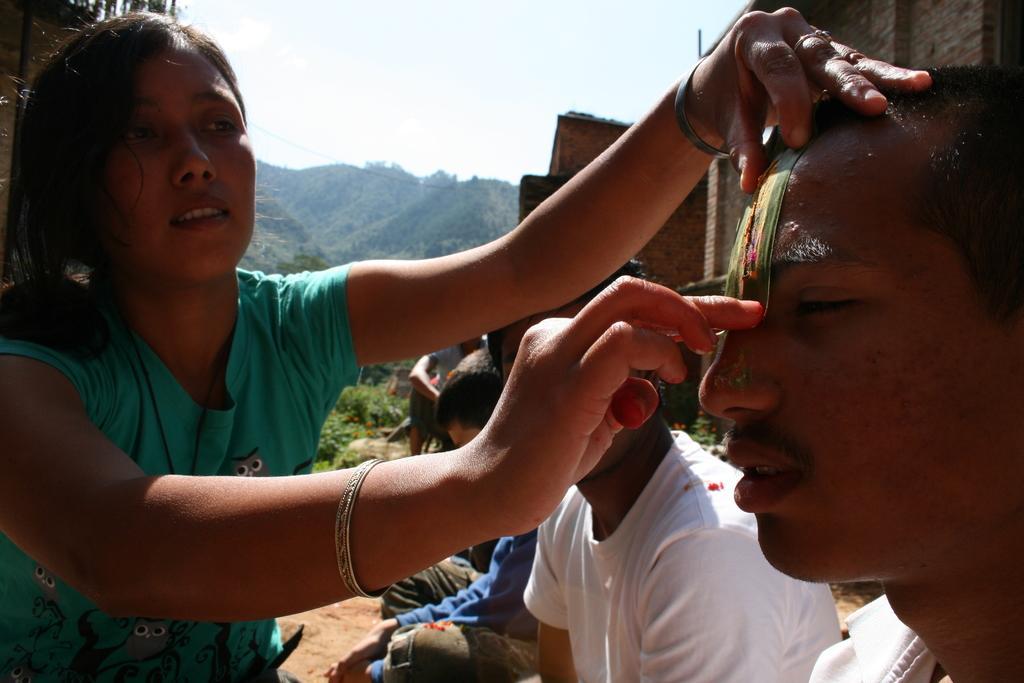In one or two sentences, can you explain what this image depicts? In the foreground of this image, on the left, there is a woman holding the head of a man with an object who is on the right. In the background, there are few people, buildings, trees, mountains and the sky. 